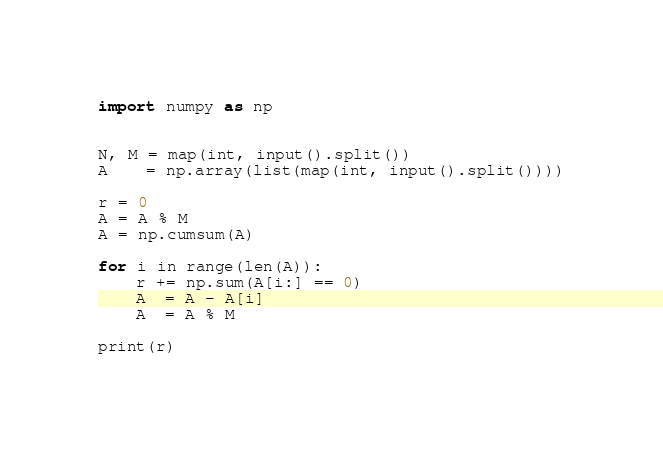Convert code to text. <code><loc_0><loc_0><loc_500><loc_500><_Python_>import numpy as np


N, M = map(int, input().split())
A    = np.array(list(map(int, input().split())))

r = 0
A = A % M
A = np.cumsum(A)

for i in range(len(A)):
    r += np.sum(A[i:] == 0)
    A  = A - A[i]
    A  = A % M

print(r)</code> 